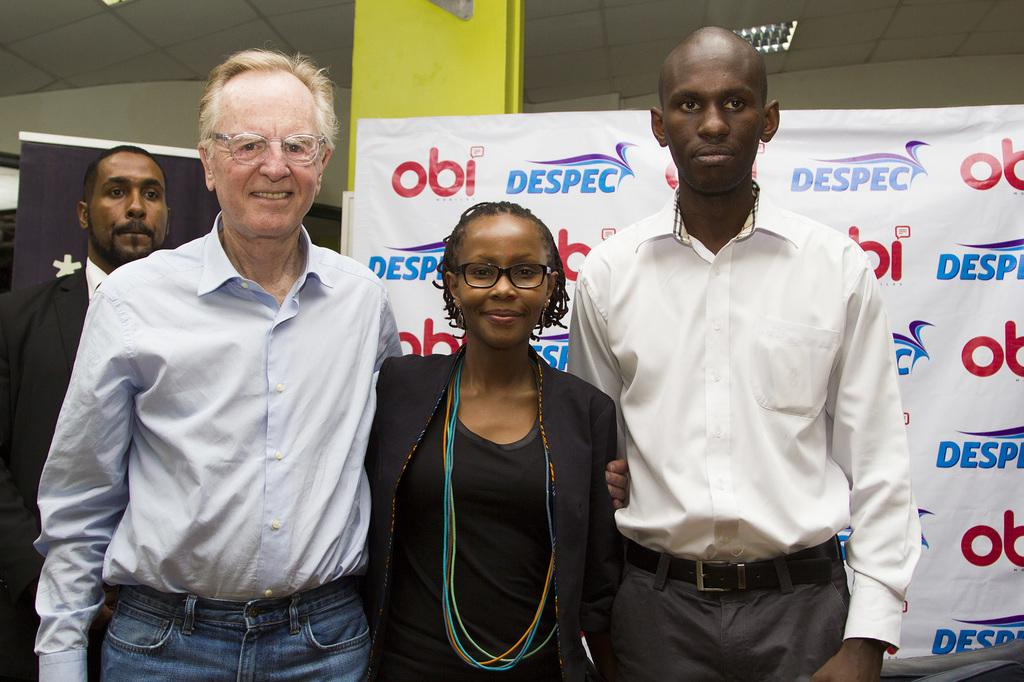What is happening in the center of the image? There are persons standing in the center of the image. What can be seen in the background of the image? There is a banner, a board, and a pillar in the background of the image. What is visible at the top of the image? There is a roof and a light visible at the top of the image. What type of drain can be seen in the image? There is no drain present in the image. 